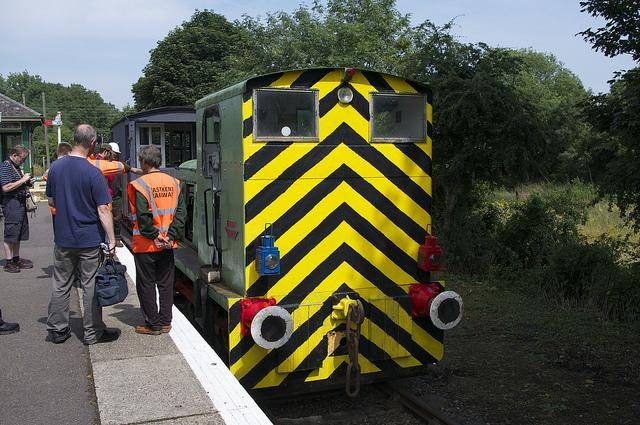Why are the men wearing orange vests? safety 